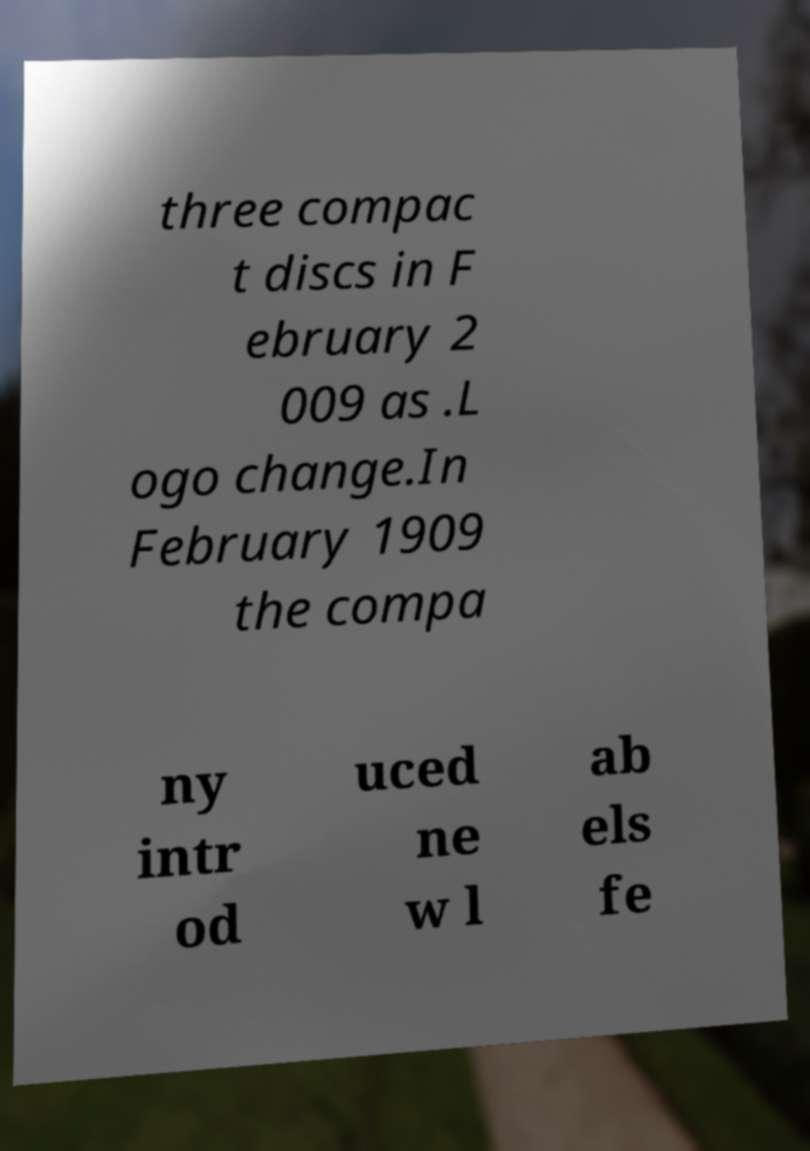What messages or text are displayed in this image? I need them in a readable, typed format. three compac t discs in F ebruary 2 009 as .L ogo change.In February 1909 the compa ny intr od uced ne w l ab els fe 